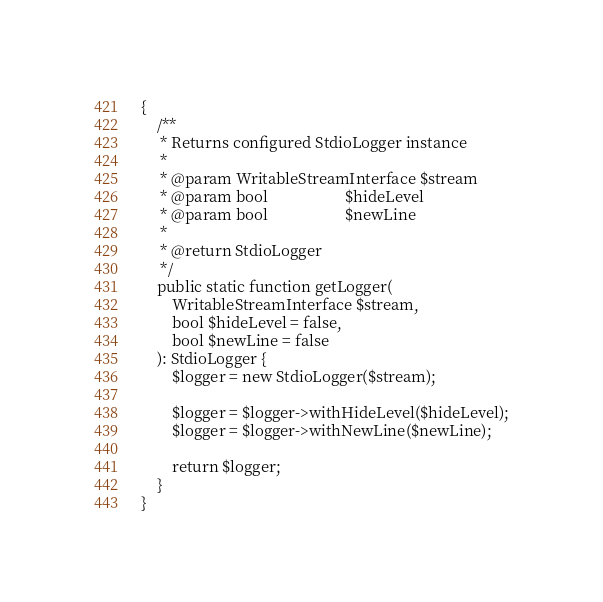<code> <loc_0><loc_0><loc_500><loc_500><_PHP_>{
    /**
     * Returns configured StdioLogger instance
     *
     * @param WritableStreamInterface $stream
     * @param bool                    $hideLevel
     * @param bool                    $newLine
     *
     * @return StdioLogger
     */
    public static function getLogger(
        WritableStreamInterface $stream,
        bool $hideLevel = false,
        bool $newLine = false
    ): StdioLogger {
        $logger = new StdioLogger($stream);

        $logger = $logger->withHideLevel($hideLevel);
        $logger = $logger->withNewLine($newLine);

        return $logger;
    }
}
</code> 